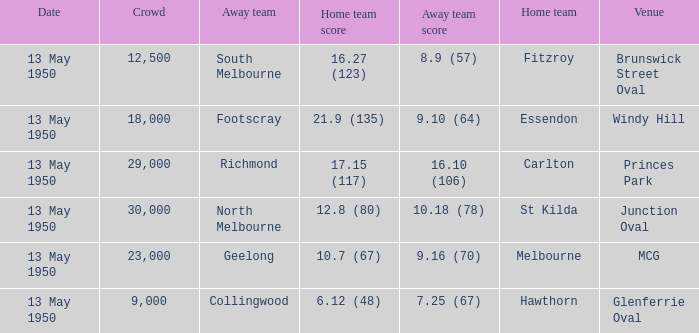Who was the away team that played Fitzroy on May 13, 1950 at Brunswick Street Oval. South Melbourne. 